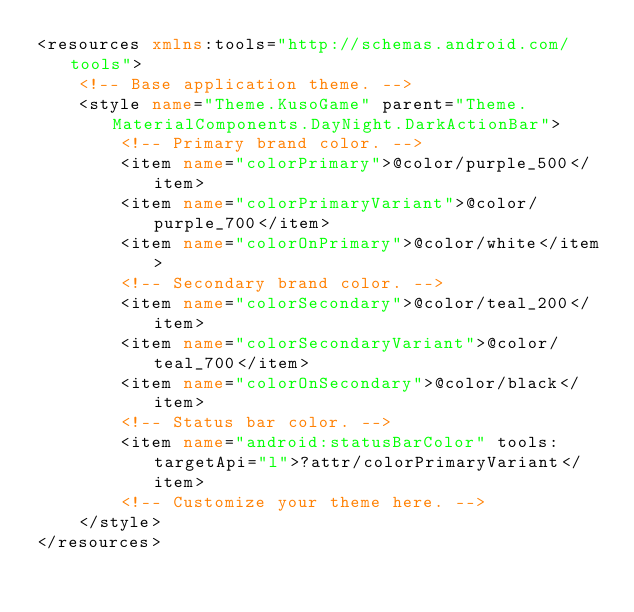<code> <loc_0><loc_0><loc_500><loc_500><_XML_><resources xmlns:tools="http://schemas.android.com/tools">
    <!-- Base application theme. -->
    <style name="Theme.KusoGame" parent="Theme.MaterialComponents.DayNight.DarkActionBar">
        <!-- Primary brand color. -->
        <item name="colorPrimary">@color/purple_500</item>
        <item name="colorPrimaryVariant">@color/purple_700</item>
        <item name="colorOnPrimary">@color/white</item>
        <!-- Secondary brand color. -->
        <item name="colorSecondary">@color/teal_200</item>
        <item name="colorSecondaryVariant">@color/teal_700</item>
        <item name="colorOnSecondary">@color/black</item>
        <!-- Status bar color. -->
        <item name="android:statusBarColor" tools:targetApi="l">?attr/colorPrimaryVariant</item>
        <!-- Customize your theme here. -->
    </style>
</resources></code> 